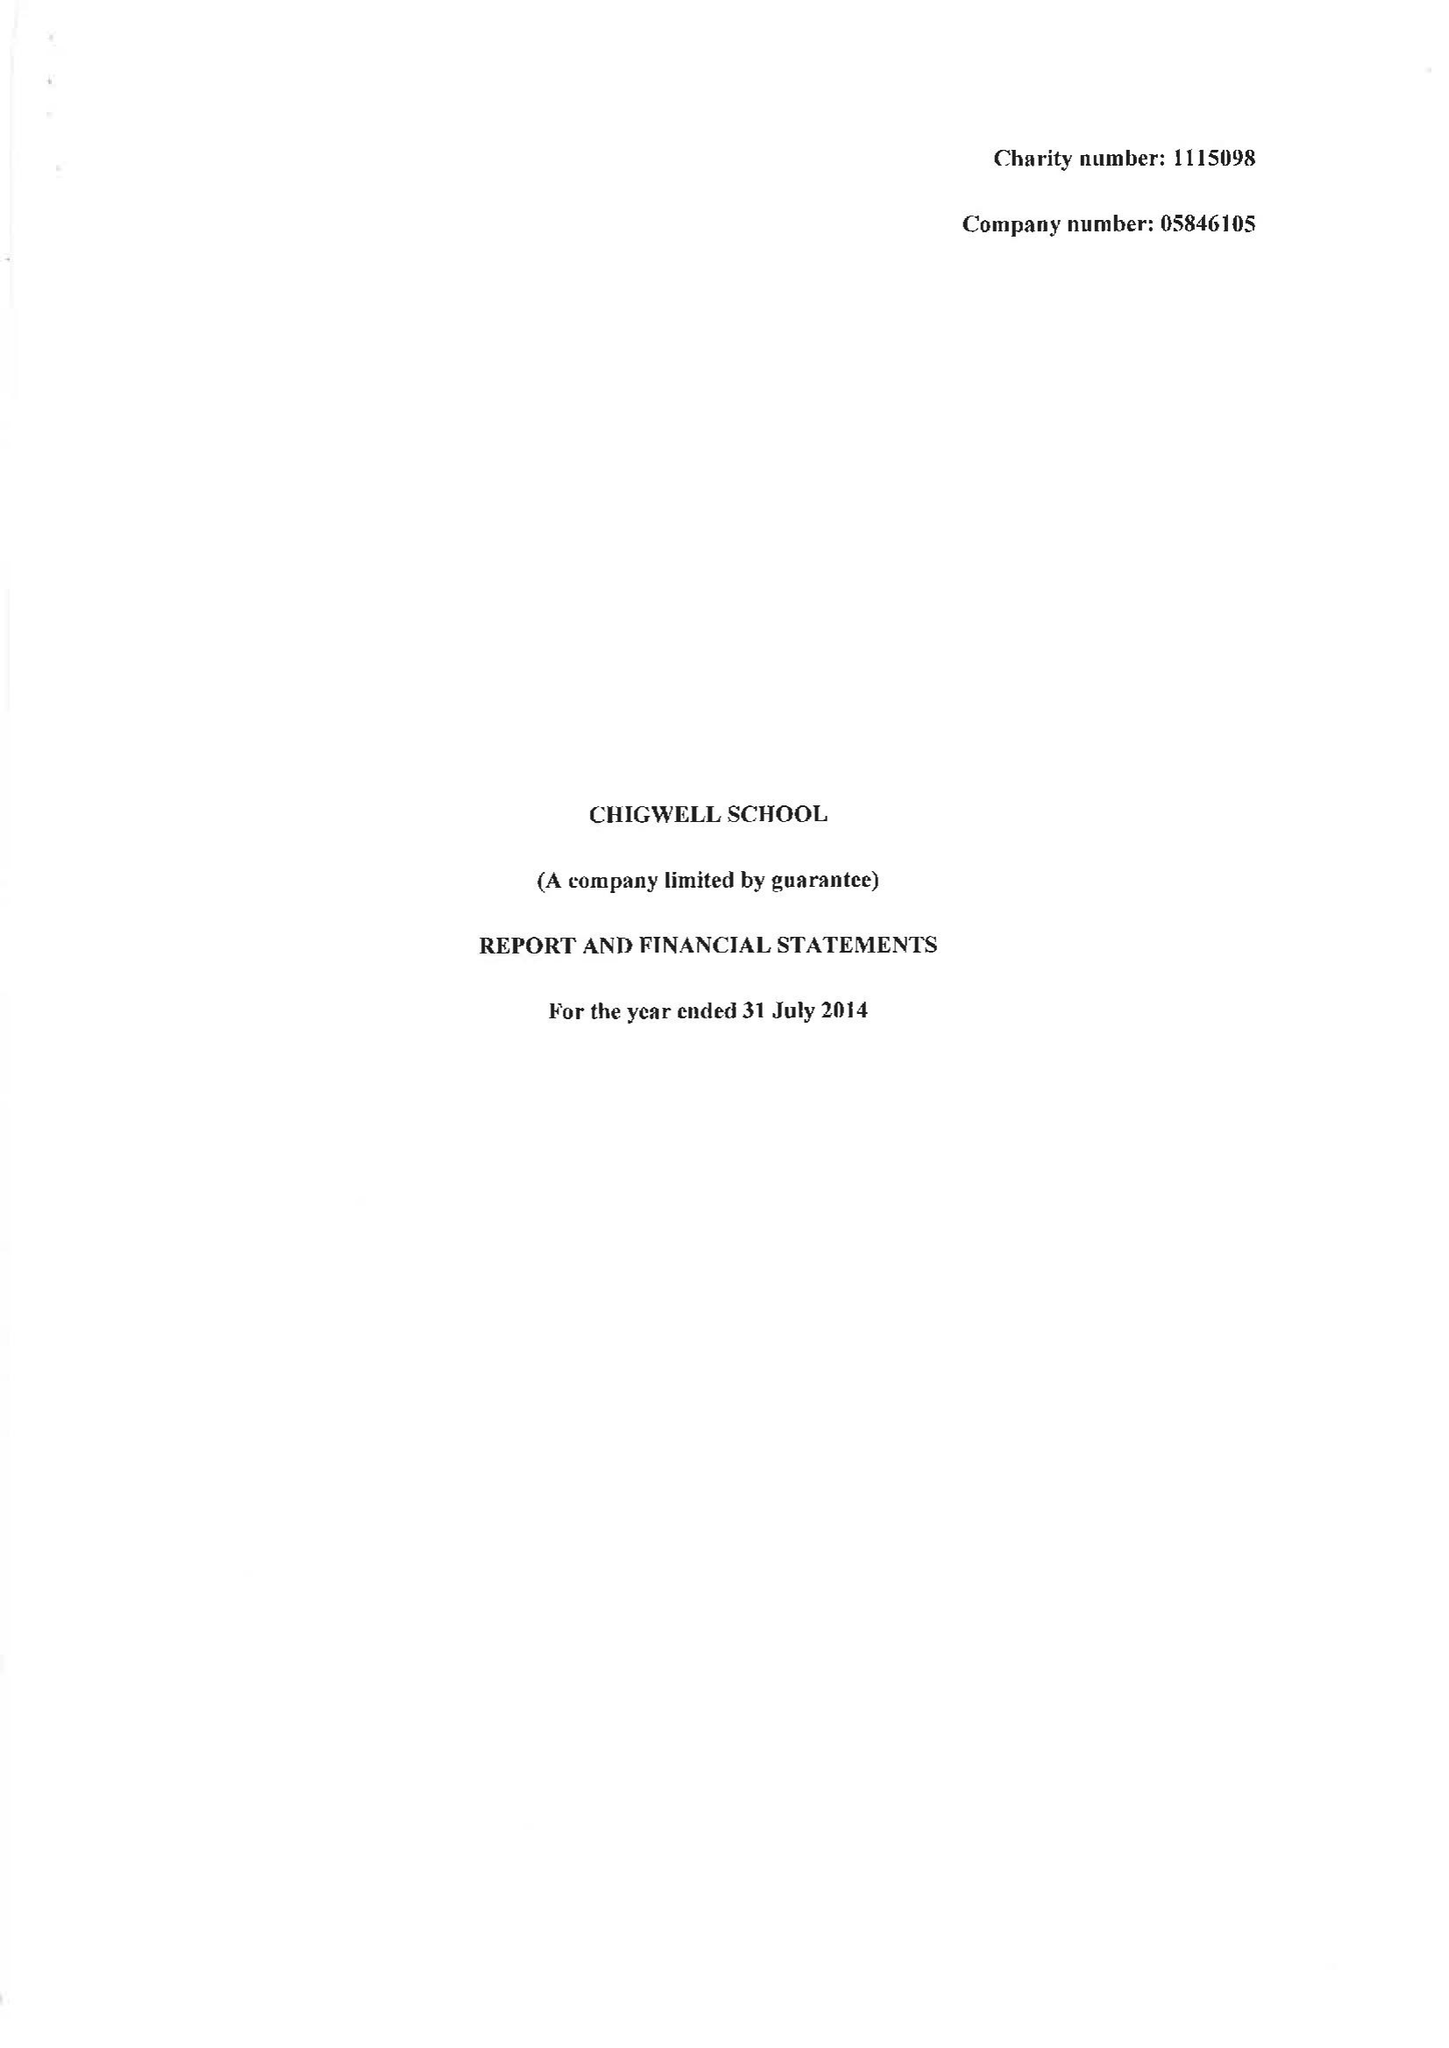What is the value for the charity_number?
Answer the question using a single word or phrase. 1115098 